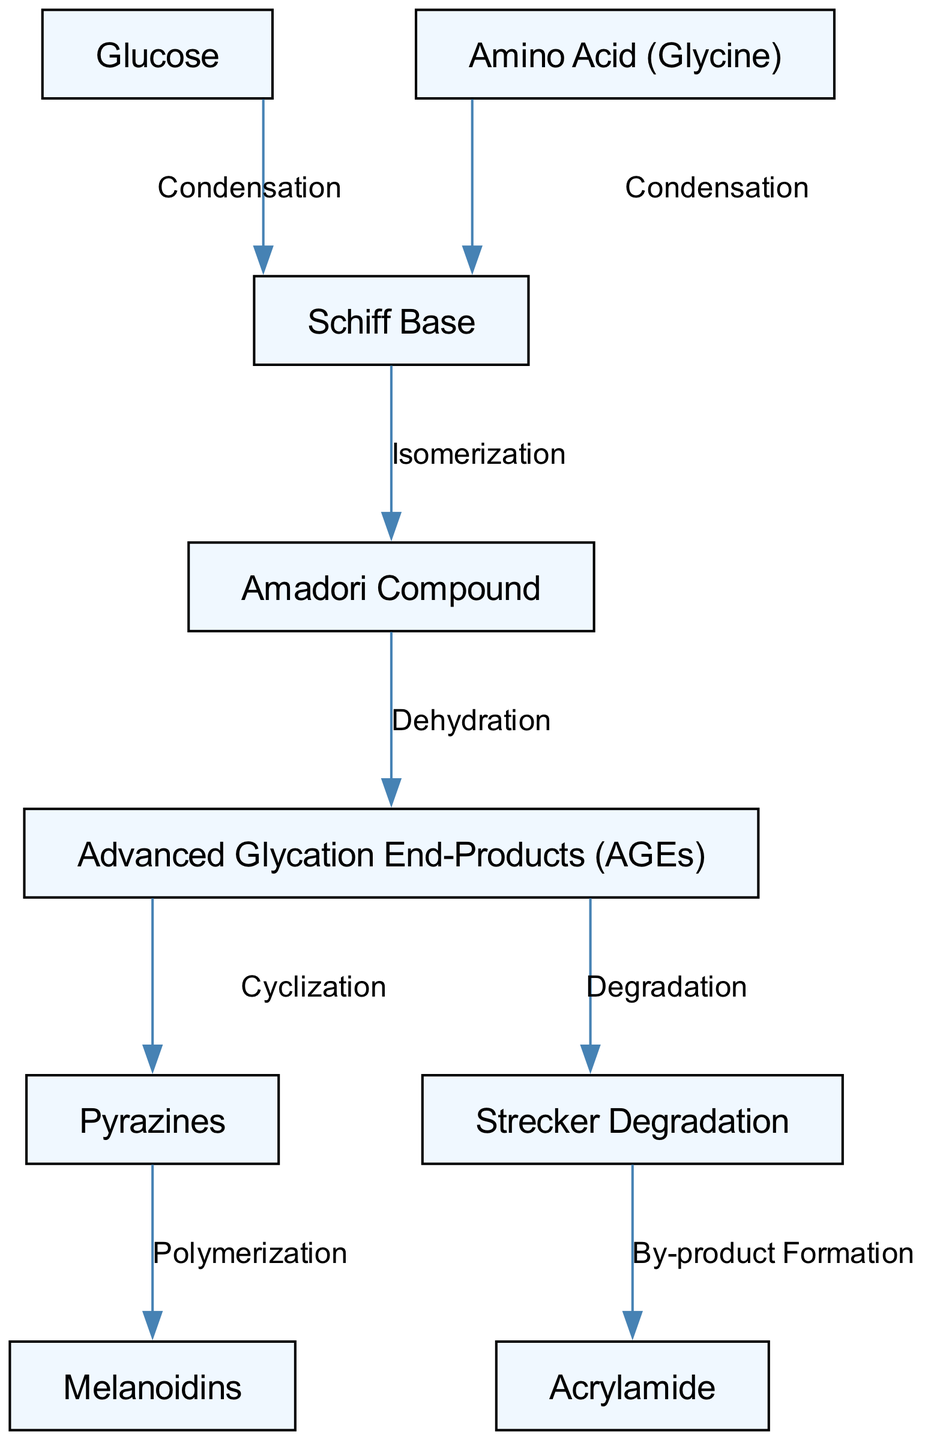What are the reactants in the first step of the Maillard reaction? The first step involves condensation reactions of glucose and glycine, indicated by the edges leading to the Schiff Base node.
Answer: Glucose and Amino Acid (Glycine) What is the product formed after the Schiff Base? The product formed after the Schiff Base is the Amadori Compound, as shown by the directed edge labeled "Isomerization."
Answer: Amadori Compound How many nodes are there in the diagram? Counting all unique entities in the diagram, there are nine nodes representing various compounds and products involved in the reaction pathway.
Answer: Nine Which compound can be formed from the Advanced Glycation End-Products through degradation? The degradation of Advanced Glycation End-Products leads to the formation of acrylamide, as represented by the directed edge coming from node 5 to node 8.
Answer: Acrylamide What type of chemical reaction connects the Amadori Compound to Advanced Glycation End-Products? The connection is made through a dehydration process, as indicated by the labeled edge proceeding from the Amadori Compound to the Advanced Glycation End-Products.
Answer: Dehydration Which final product is generated from Pyrazines through polymerization? The final product resulting from the polymerization of Pyrazines is melanoidins, as seen by the directed edge from Pyrazines to Melanoidins.
Answer: Melanoidins What is the role of Schiff Base in the pathway? The Schiff Base acts as an intermediate compound formed by the initial condensation reactions, connecting glucose and amin acids before further reaction steps occur.
Answer: Intermediate How many edges connect the nodes in this diagram? By counting all the directed connections or edges between the nodes, there are eight edges that illustrate the transformation from reactants to products.
Answer: Eight What type of reaction leads to the formation of Pyrazines from Advanced Glycation End-Products? The formation of Pyrazines from Advanced Glycation End-Products occurs through the cyclization reaction as indicated by the directed edge connecting the two nodes.
Answer: Cyclization 